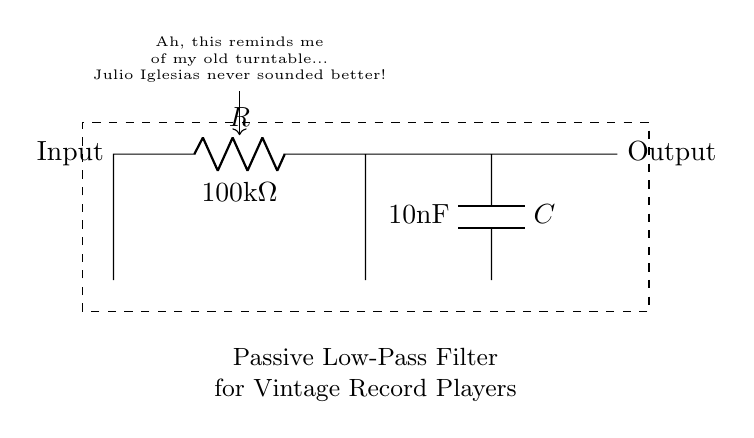What type of filter is shown in the circuit? The circuit diagram represents a passive low-pass filter, as indicated by the components used (a resistor and a capacitor) arranged in a specific configuration to allow low frequencies and attenuate high frequencies.
Answer: passive low-pass filter What is the resistance value in the circuit? The resistance value is specified as 100kΩ, which is marked next to the resistor in the diagram.
Answer: 100kΩ What is the capacitance value in the circuit? The capacitance value is noted as 10nF next to the capacitor in the circuit, indicating its capacity to store electric charge.
Answer: 10nF What does the dashed rectangle indicate in the diagram? The dashed rectangle surrounds the circuit components, typically signifying the boundaries of the circuit or separating it from other elements, thus highlighting the area of interest.
Answer: boundaries of the circuit How does the output signal relate to the input signal in this filter? In a low-pass filter, the output signal retains low-frequency components of the input while attenuating the higher frequencies, which means that the output will vary based on the frequency content of the input signal.
Answer: low-frequency components retained What happens to high-frequency noise when using this filter? High-frequency noise is attenuated, meaning that as the frequency of a noise signal increases, the filter will reduce its amplitude at the output, thereby cleaning up the signal.
Answer: attenuated Why might someone use this filter with a vintage record player? Vintage record players often pick up unwanted noise, and using a low-pass filter helps eliminate high-frequency noise, allowing for a clearer playback of music, especially for smooth sounds like those of Julio Iglesias.
Answer: clear playback of music 